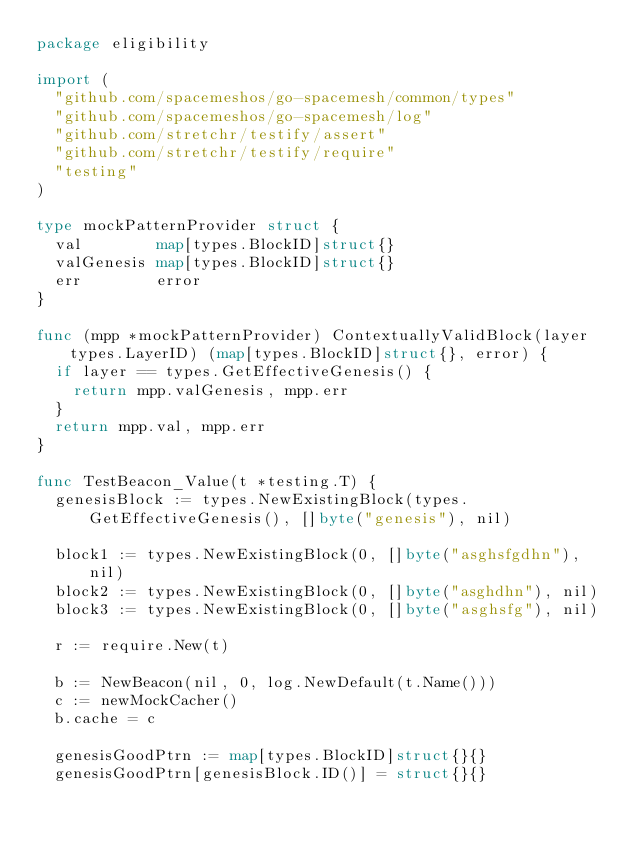<code> <loc_0><loc_0><loc_500><loc_500><_Go_>package eligibility

import (
	"github.com/spacemeshos/go-spacemesh/common/types"
	"github.com/spacemeshos/go-spacemesh/log"
	"github.com/stretchr/testify/assert"
	"github.com/stretchr/testify/require"
	"testing"
)

type mockPatternProvider struct {
	val        map[types.BlockID]struct{}
	valGenesis map[types.BlockID]struct{}
	err        error
}

func (mpp *mockPatternProvider) ContextuallyValidBlock(layer types.LayerID) (map[types.BlockID]struct{}, error) {
	if layer == types.GetEffectiveGenesis() {
		return mpp.valGenesis, mpp.err
	}
	return mpp.val, mpp.err
}

func TestBeacon_Value(t *testing.T) {
	genesisBlock := types.NewExistingBlock(types.GetEffectiveGenesis(), []byte("genesis"), nil)

	block1 := types.NewExistingBlock(0, []byte("asghsfgdhn"), nil)
	block2 := types.NewExistingBlock(0, []byte("asghdhn"), nil)
	block3 := types.NewExistingBlock(0, []byte("asghsfg"), nil)

	r := require.New(t)

	b := NewBeacon(nil, 0, log.NewDefault(t.Name()))
	c := newMockCacher()
	b.cache = c

	genesisGoodPtrn := map[types.BlockID]struct{}{}
	genesisGoodPtrn[genesisBlock.ID()] = struct{}{}
</code> 